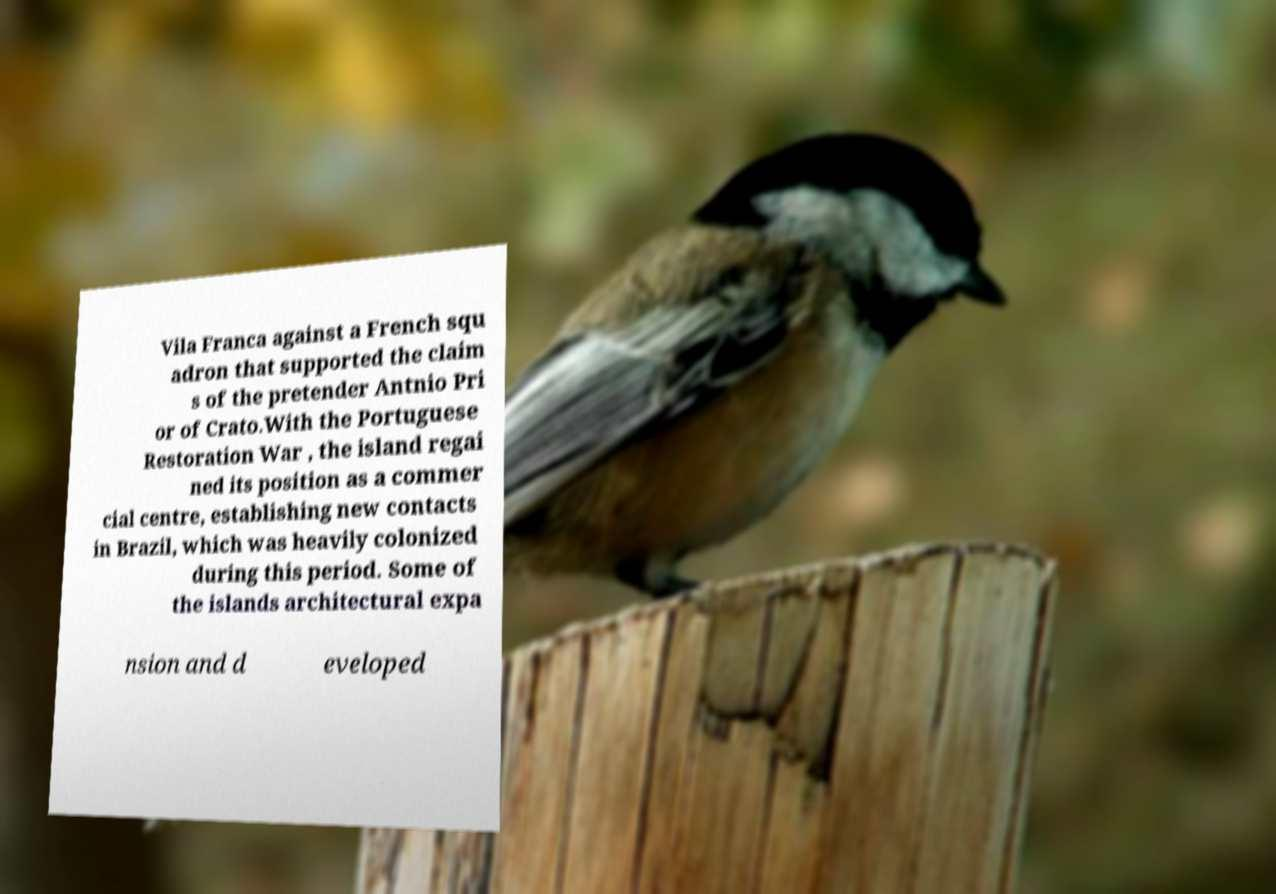Could you extract and type out the text from this image? Vila Franca against a French squ adron that supported the claim s of the pretender Antnio Pri or of Crato.With the Portuguese Restoration War , the island regai ned its position as a commer cial centre, establishing new contacts in Brazil, which was heavily colonized during this period. Some of the islands architectural expa nsion and d eveloped 